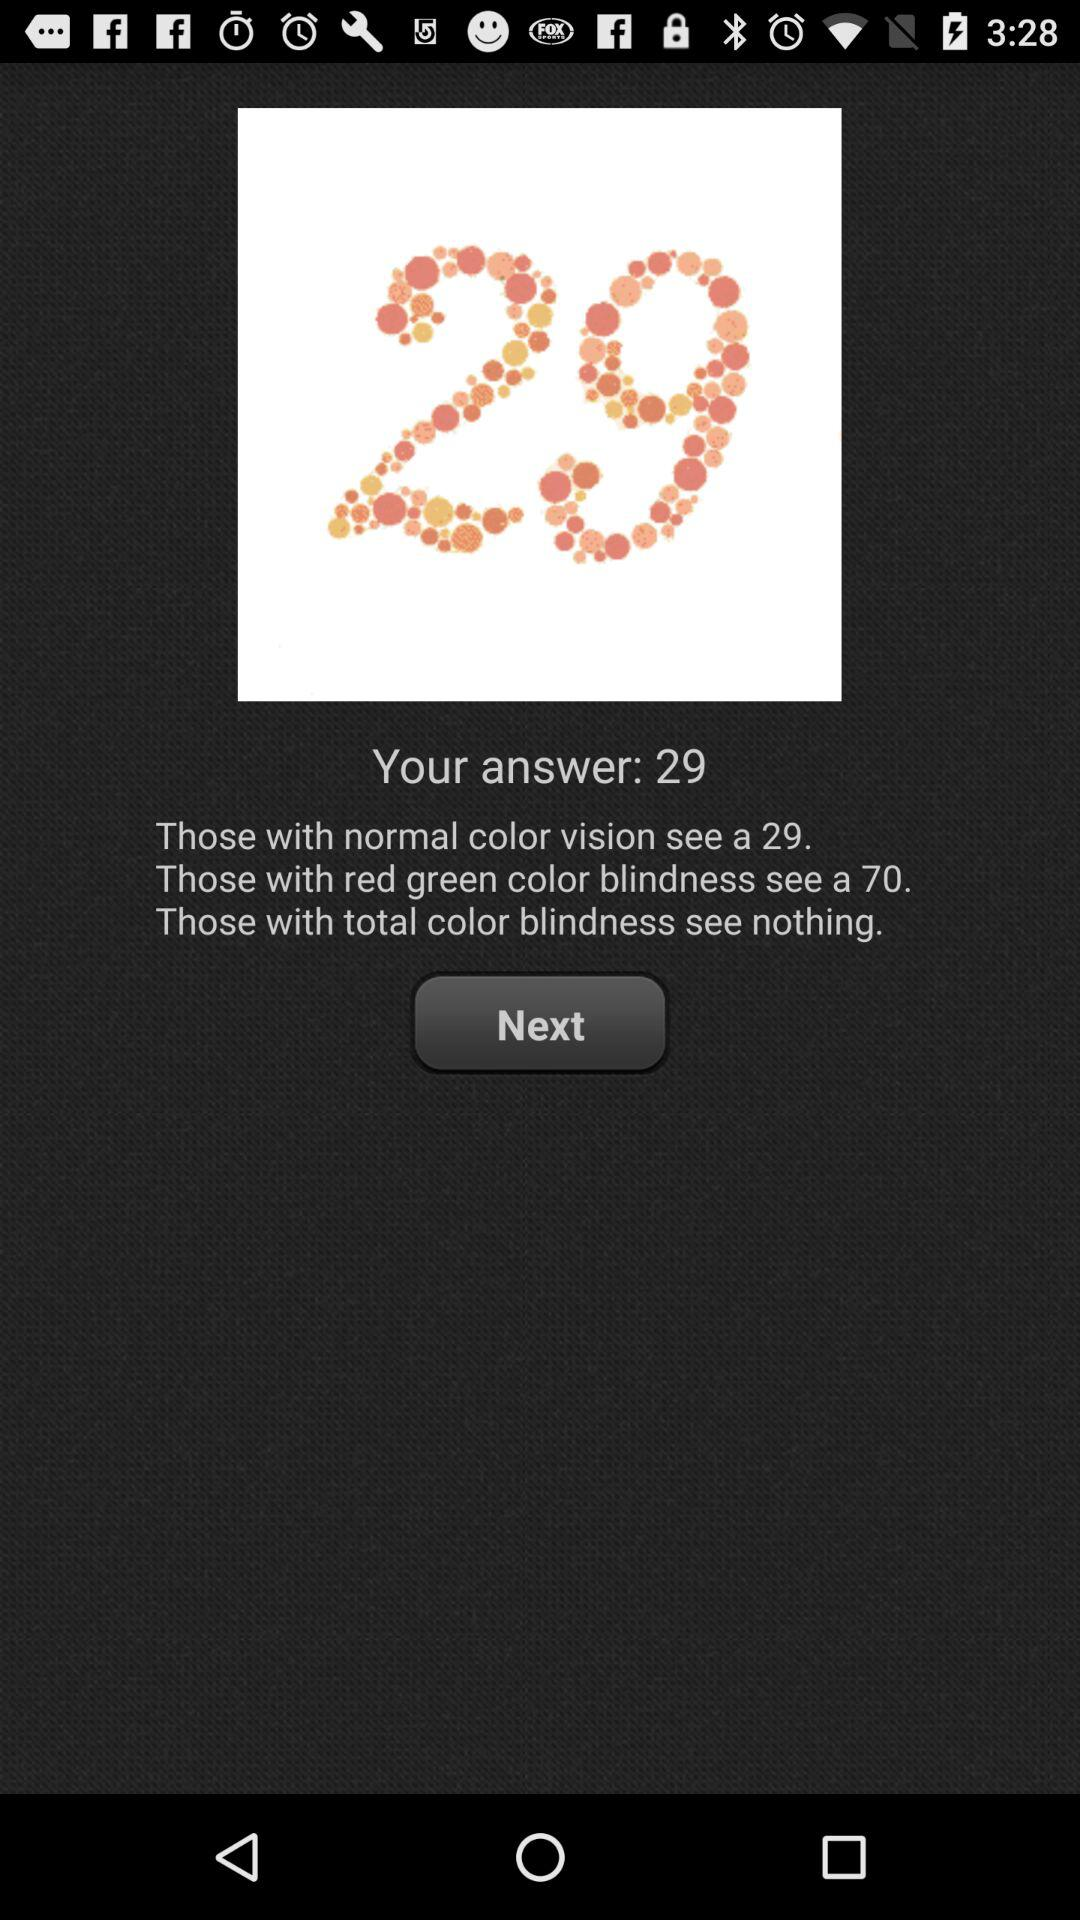Is the user colorblind?
When the provided information is insufficient, respond with <no answer>. <no answer> 